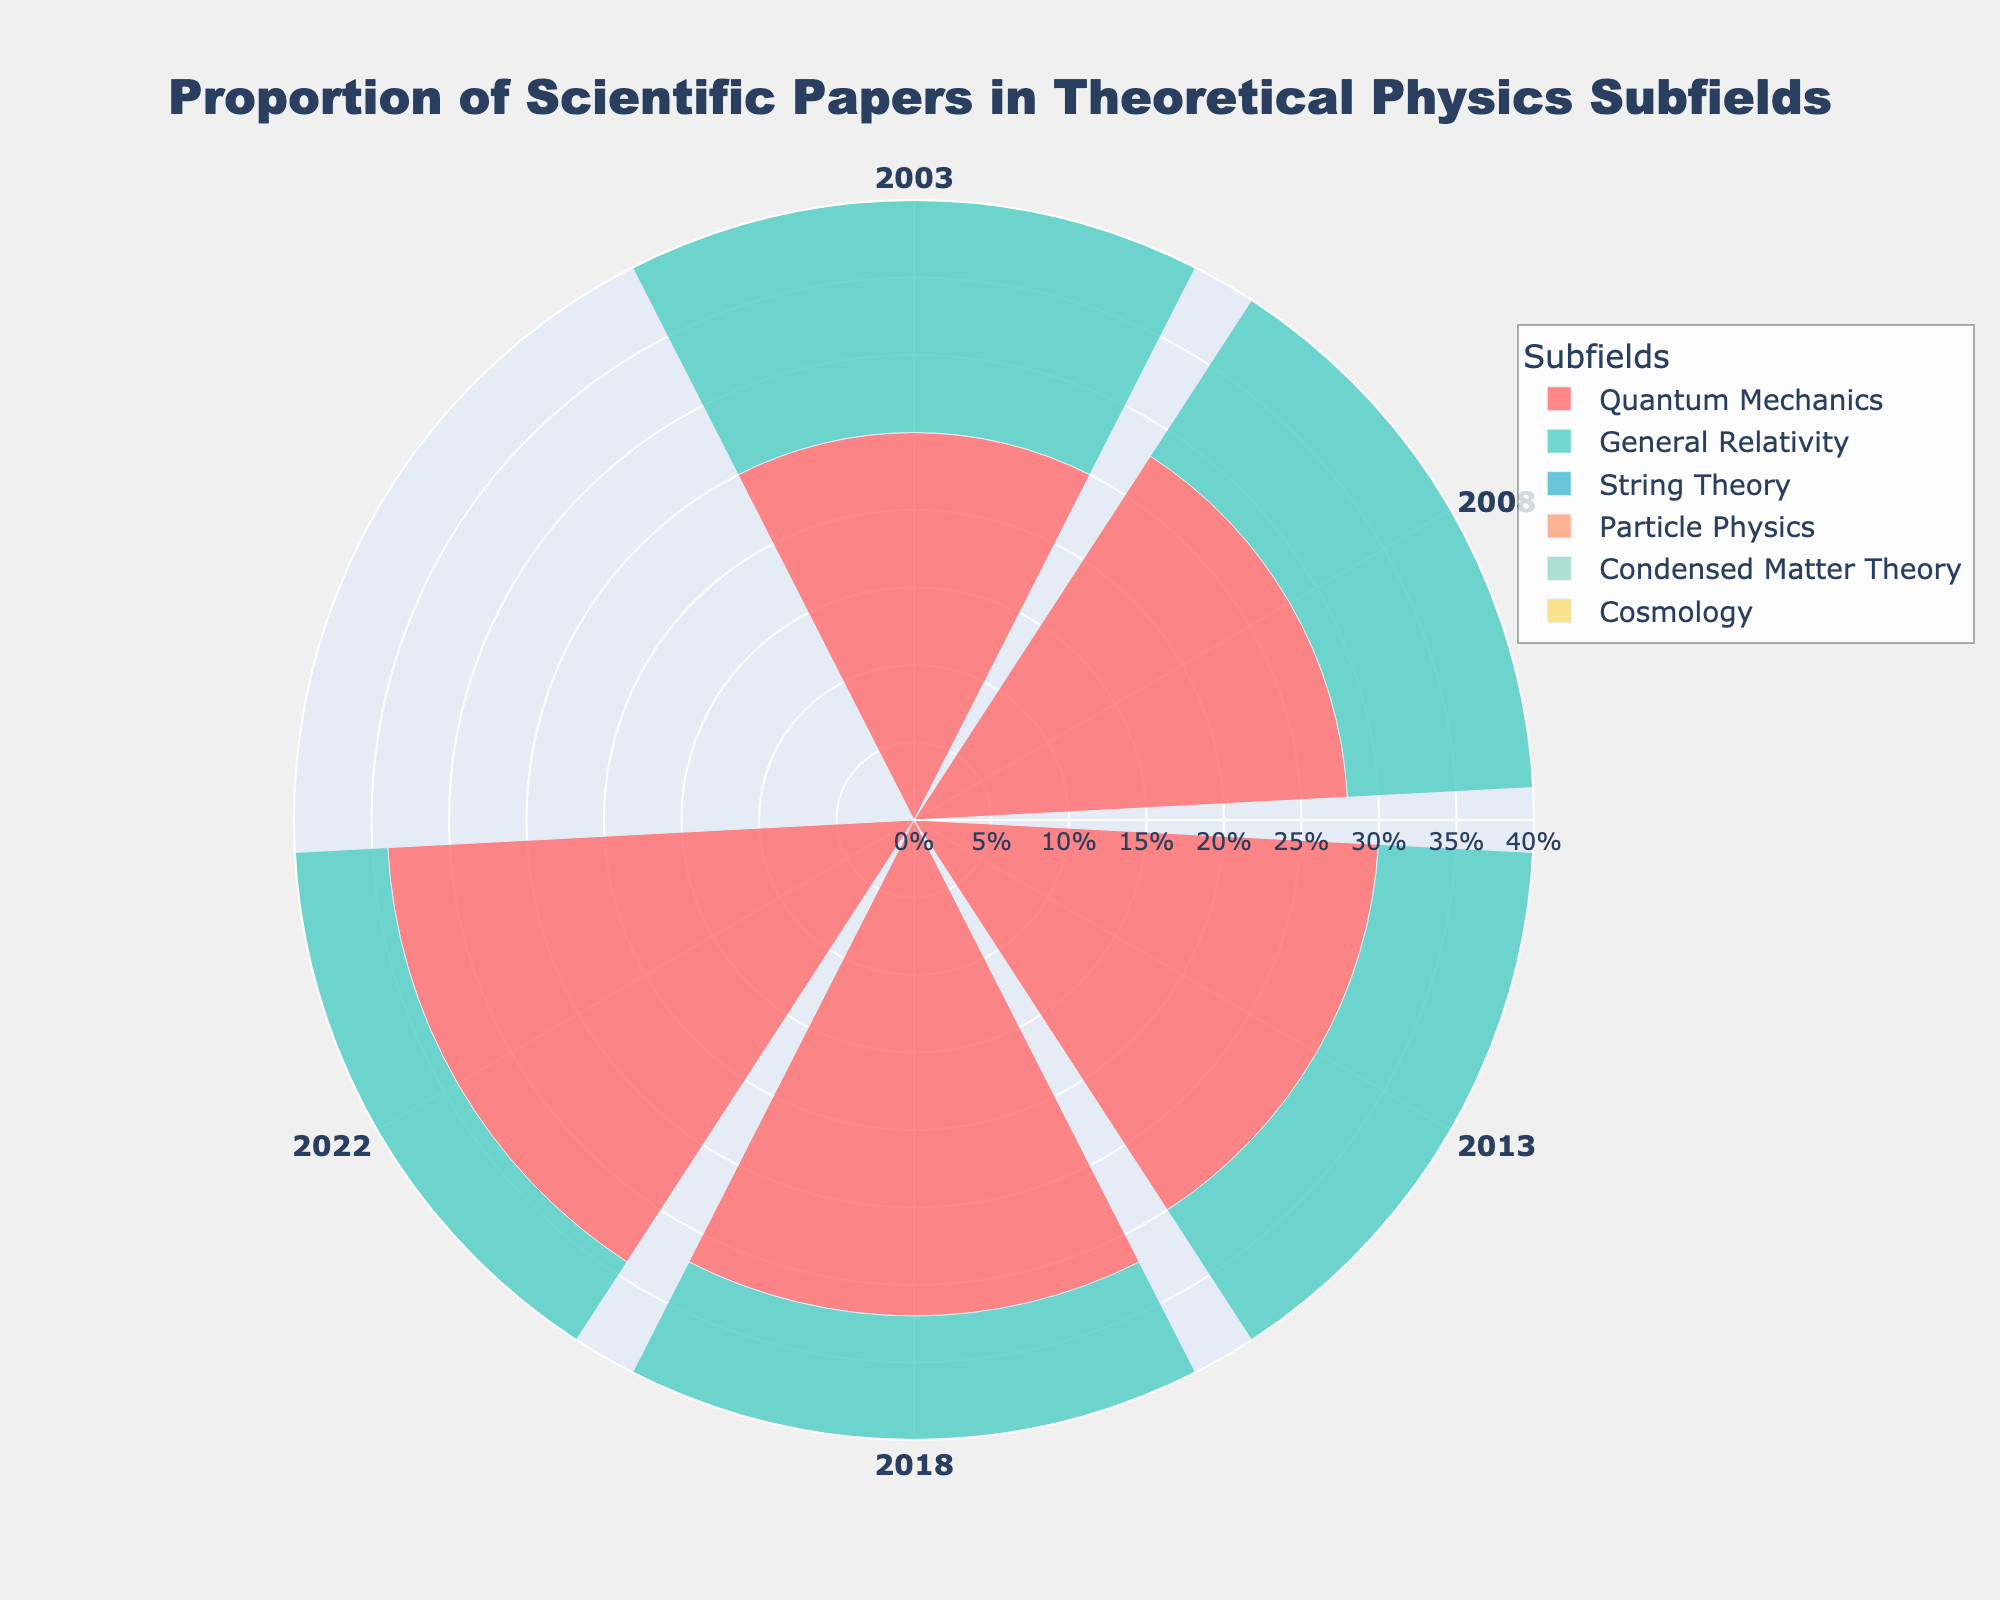What is the title of the chart? The title is usually located at the top center of the chart. In this case, the title is "Proportion of Scientific Papers in Theoretical Physics Subfields", which clearly indicates the content.
Answer: Proportion of Scientific Papers in Theoretical Physics Subfields Which subfield had the highest proportion of papers published in 2022? By examining the radial extent of the bars for the year 2022, we can see that Quantum Mechanics has the highest proportion as represented by the largest radial distance.
Answer: Quantum Mechanics How did the proportion of papers in General Relativity change from 2003 to 2022? By comparing the radial lengths of the bars for General Relativity between 2003 and 2022, we observe a decrease from 0.20 in 2003 to 0.15 in 2022.
Answer: Decreased What is the average proportion of papers published in String Theory over the years displayed? The proportions for String Theory in the years shown are 0.15, 0.20, 0.22, 0.25, and 0.27. Summing them up results in 1.09, and dividing this by the number of instances (5) gives 0.218.
Answer: 0.218 Which subfield showed a consistent increase in the proportion of published papers over the specified years? By examining all subfields and looking for a trend of consistent rise in each corresponding radial length from earlier to later years, Quantum Mechanics meets this criterion.
Answer: Quantum Mechanics What is the proportion difference in papers between Particle Physics and Condensed Matter Theory in 2003? The proportion for Particle Physics in 2003 is 0.20, and for Condensed Matter Theory, it is 0.10. The difference is calculated as 0.20 - 0.10 = 0.10.
Answer: 0.10 How does the trend in the proportion of papers in Cosmology compare to Particle Physics over the years? By following the radial lengths, both start at 0.10 and 0.20 respectively in 2003. Cosmology slightly increases to 0.13 by 2022, while Particle Physics shows a decline to 0.12. Cosmology trends slightly upwards while Particle Physics trends downwards.
Answer: Cosmology trends upward, Particle Physics trends downward What is the proportion of papers in Condensed Matter Theory in 2018? Check the bar for Condensed Matter Theory corresponding to the year 2018, which shows a proportion of 0.15.
Answer: 0.15 Which subfield had the smallest proportion in 2008 and what is its value? By comparing the radial lengths for all subfields for 2008, Condensed Matter Theory is the smallest with a proportion of 0.12.
Answer: Condensed Matter Theory, 0.12 